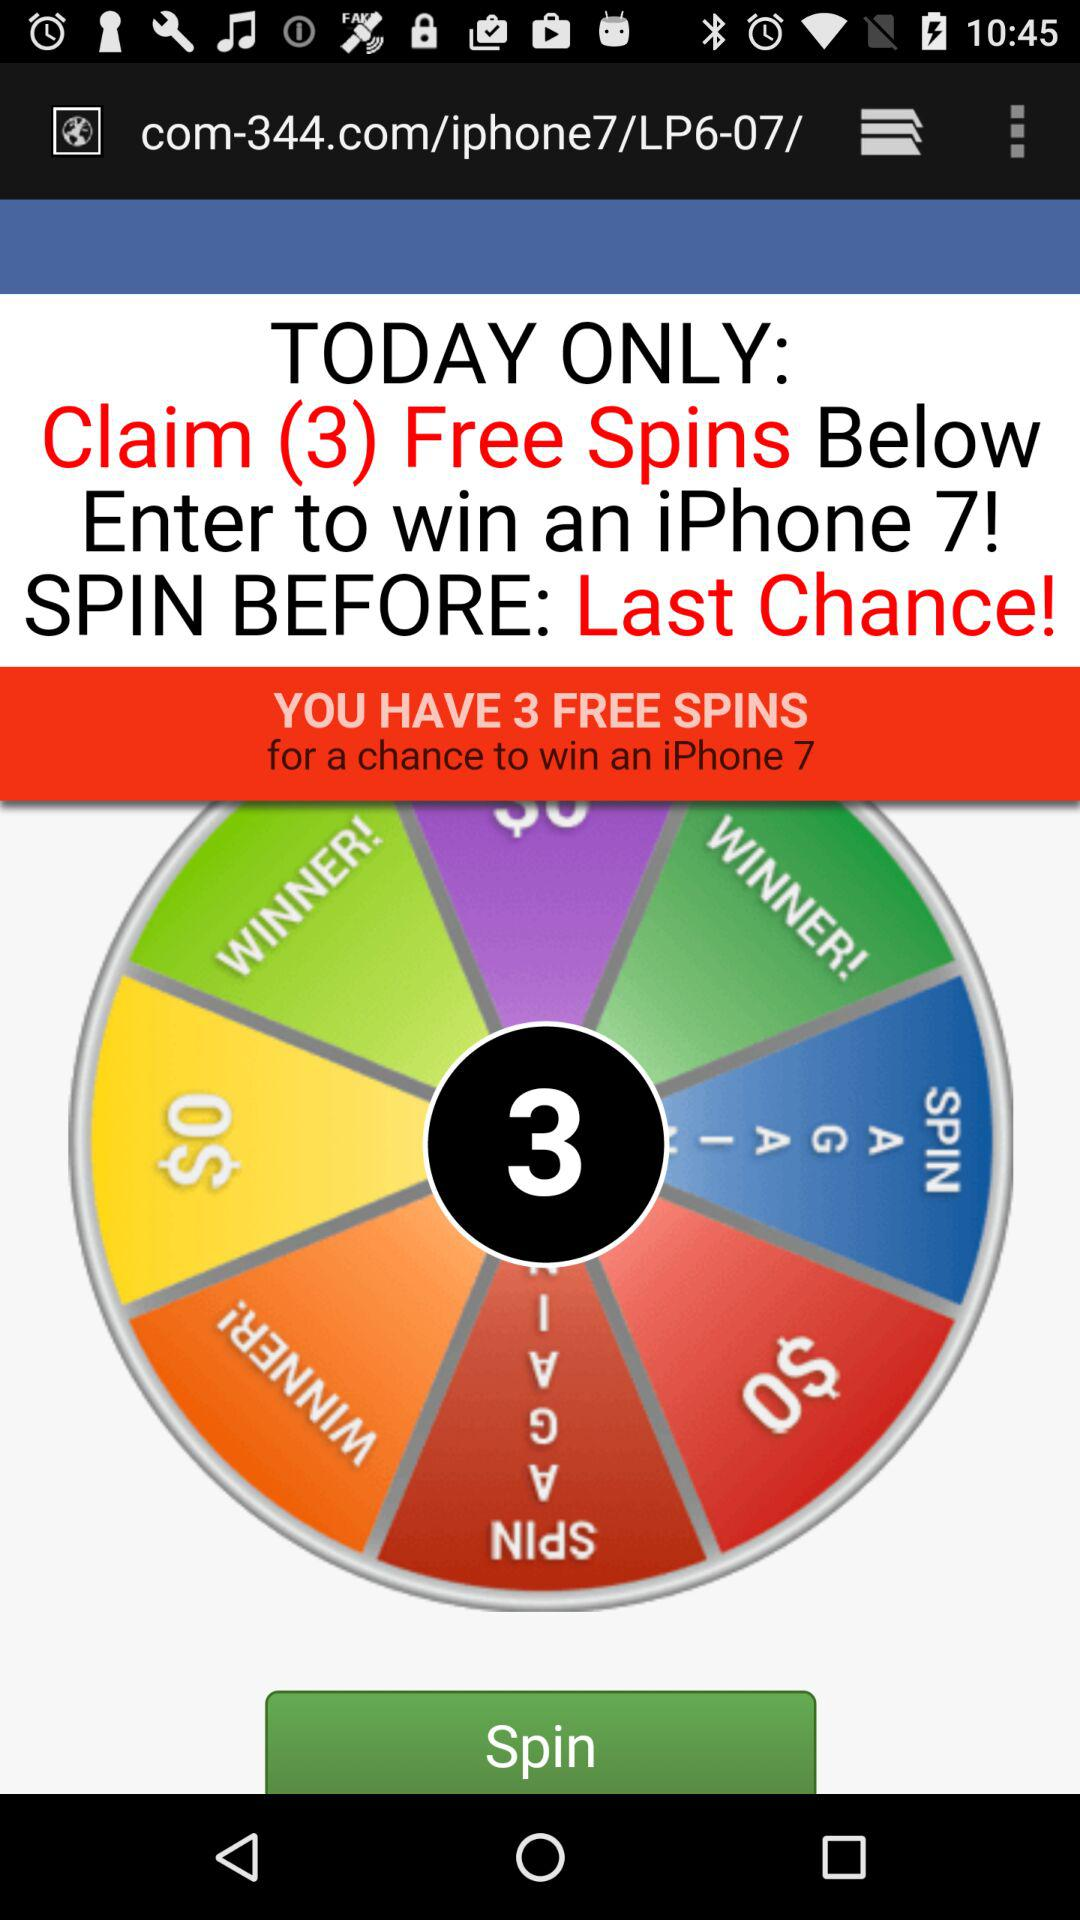How many spins do I have left?
Answer the question using a single word or phrase. 3 